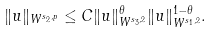<formula> <loc_0><loc_0><loc_500><loc_500>\| u \| _ { W ^ { s _ { 2 } , p } } \leq C \| u \| _ { W ^ { s _ { 3 } , 2 } } ^ { \theta } \| u \| _ { W ^ { s _ { 1 } , 2 } } ^ { 1 - \theta } .</formula> 